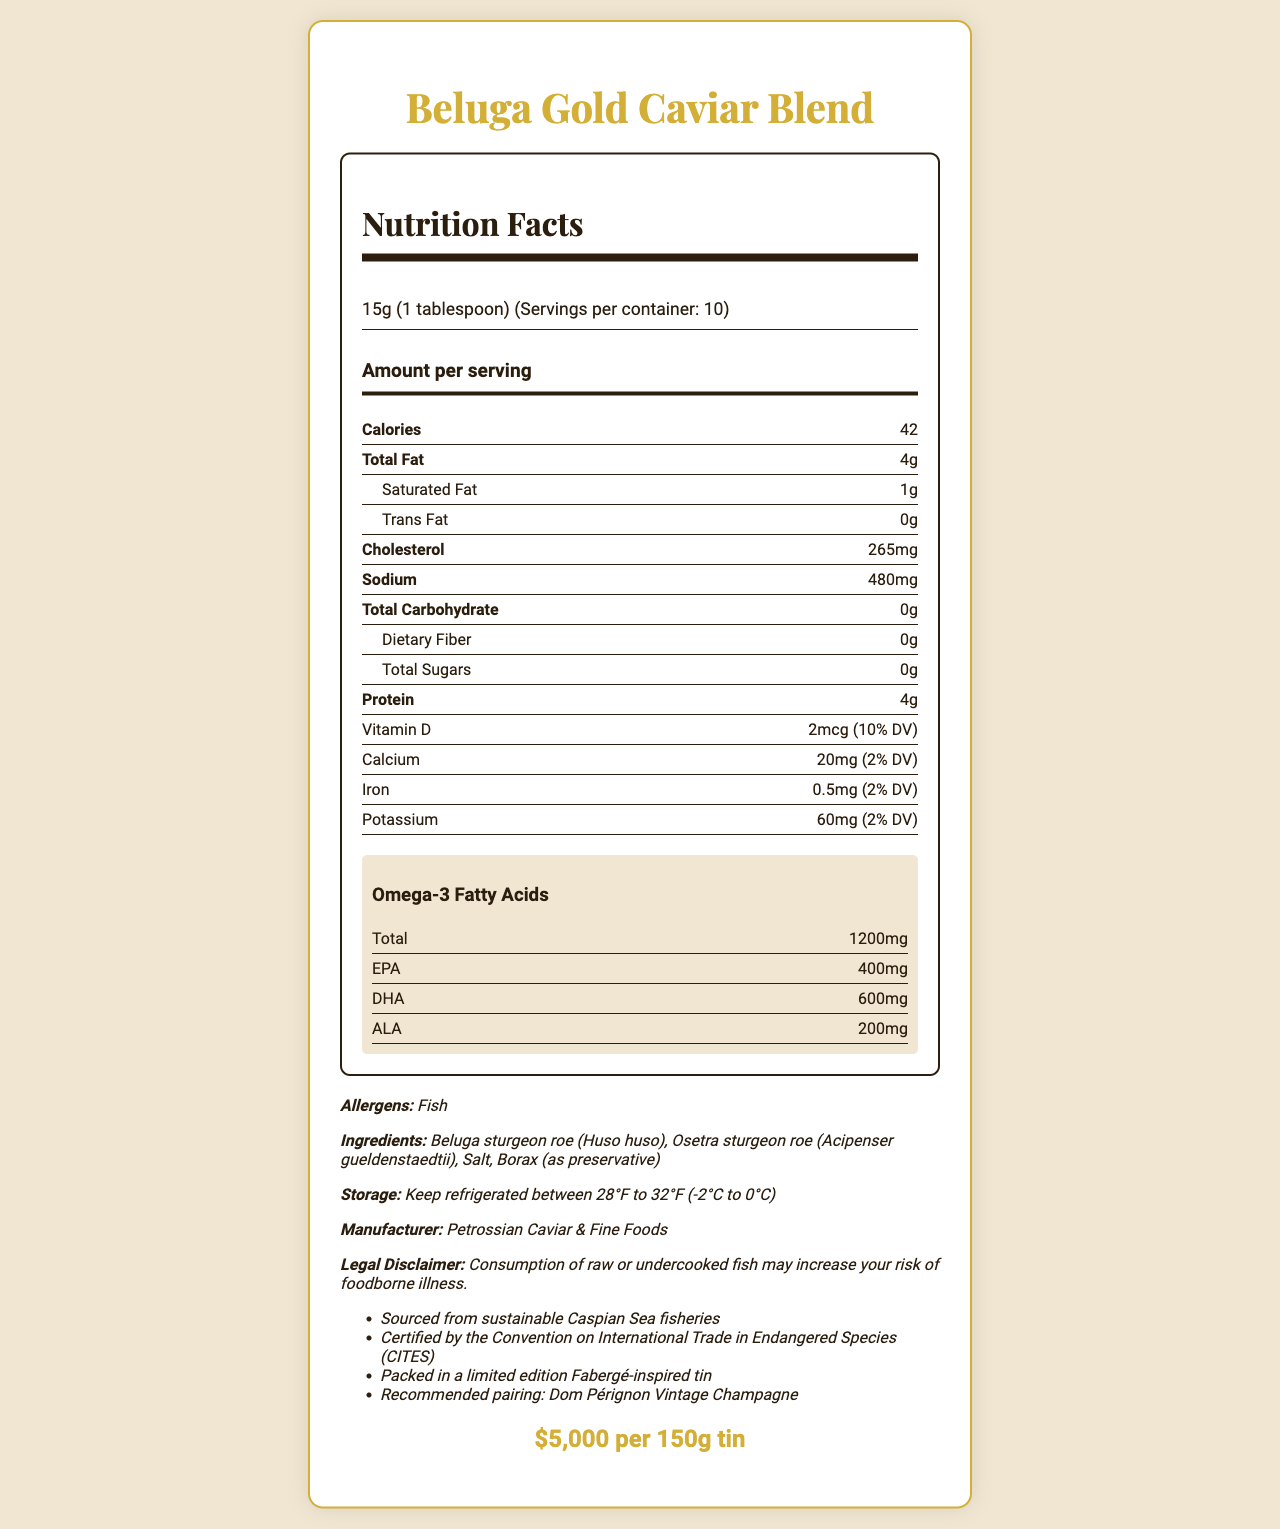What is the serving size for Beluga Gold Caviar Blend? The serving size is listed in the serving information section of the label.
Answer: 15g (1 tablespoon) How many servings are there in a container of Beluga Gold Caviar Blend? The number of servings per container is mentioned as "Servings per container: 10" in the serving information section.
Answer: 10 What is the total amount of Omega-3 fatty acids per serving? The document lists the omega-3 fatty acids under a dedicated section and states the total amount as 1200mg.
Answer: 1200mg How much Vitamin D is in one serving of the caviar? The vitamin D content is listed in the nutrient row section under the serving information.
Answer: 2mcg (10% DV) Which manufacturer produces Beluga Gold Caviar Blend? The manufacturer's name can be found in the additional information section.
Answer: Petrossian Caviar & Fine Foods What is the main ingredient in Beluga Gold Caviar Blend? A. Salt B. Beluga sturgeon roe C. Osetra sturgeon roe D. Borax The main ingredients are listed, and Beluga sturgeon roe is mentioned first.
Answer: B How much cholesterol is there per serving? A. 150mg B. 200mg C. 265mg D. 300mg The amount of cholesterol per serving is listed as 265mg in the nutrient row section.
Answer: C True or False: The Beluga Gold Caviar Blend contains fiber. The nutrient row section lists dietary fiber content as 0g, indicating there is no fiber.
Answer: False What is the price of one tin of Beluga Gold Caviar Blend? The price is displayed prominently at the bottom of the document in the price section.
Answer: $5,000 per 150g tin How is the Beluga Gold Caviar Blend recommended to be paired? The additional information section suggests pairing it with Dom Pérignon Vintage Champagne.
Answer: Dom Pérignon Vintage Champagne What are the storage instructions for the Beluga Gold Caviar Blend? The storage instructions are detailed in the additional information section.
Answer: Keep refrigerated between 28°F to 32°F (-2°C to 0°C) What is the total fat content per serving? The total fat content is clearly indicated in the nutrient row section.
Answer: 4g Summarize the entire document. The document is a comprehensive nutritional label for Beluga Gold Caviar Blend, featuring all necessary nutritional values, ingredients, additional product information, and pairing recommendations.
Answer: The document provides detailed nutritional information about Beluga Gold Caviar Blend, including fat, cholesterol, sodium, protein, vitamins, and Omega-3 fatty acids. It also lists the ingredients, allergens, manufacturer details, storage instructions, and price. The caviar is packed in a limited edition tin and recommended to be paired with Dom Pérignon Vintage Champagne. What percentage of the daily value for calcium does one serving of Beluga Gold Caviar Blend provide? The calcium content is listed as 20mg (2% DV) in the nutrient row section.
Answer: 2% Who certifies the source of the caviar? The certification information is listed in the additional info section.
Answer: Certified by the Convention on International Trade in Endangered Species (CITES) From which body of water is the Beluga Gold Caviar Blend sourced? The additional information states that the blend is sourced from sustainable Caspian Sea fisheries.
Answer: Caspian Sea Is the amount of trans fat in Beluga Gold Caviar Blend high? The document lists the amount of trans fat as 0g, indicating it’s not present.
Answer: No Can you determine how many servings of protein a whole container of Beluga Gold Caviar Blend provides? Each serving has 4g of protein, and there are 10 servings per container, so the total protein amount is 4g * 10 = 40g.
Answer: 40g of protein per container What is the legal disclaimer mentioned for Beluga Gold Caviar Blend? The legal disclaimer is listed near the bottom of the document under the additional information section.
Answer: Consumption of raw or undercooked fish may increase your risk of foodborne illness. Which omega-3 fatty acid is present in the highest amount in Beluga Gold Caviar Blend? The omega-3 fatty acids section lists DHA as 600mg, being the highest among EPA, DHA, and ALA.
Answer: DHA How long can you keep Beluga Gold Caviar Blend unrefrigerated? The document states the caviar should be kept refrigerated but does not specify the duration it can be kept unrefrigerated.
Answer: Not enough information 